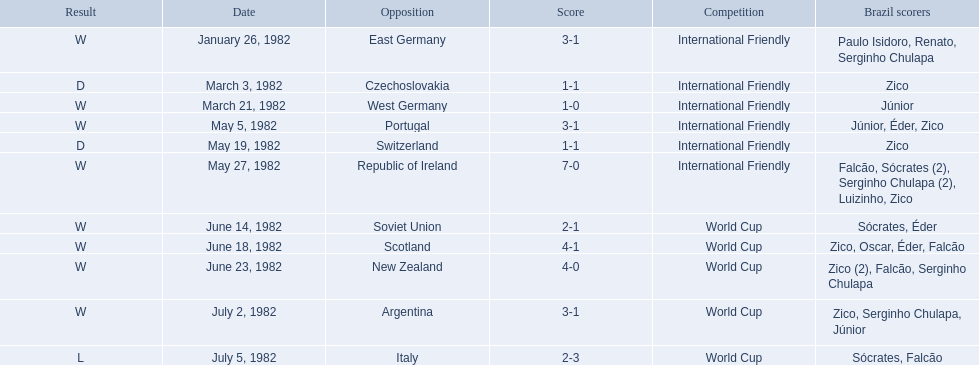What were the scores of each of game in the 1982 brazilian football games? 3-1, 1-1, 1-0, 3-1, 1-1, 7-0, 2-1, 4-1, 4-0, 3-1, 2-3. Of those, which were scores from games against portugal and the soviet union? 3-1, 2-1. And between those two games, against which country did brazil score more goals? Portugal. 